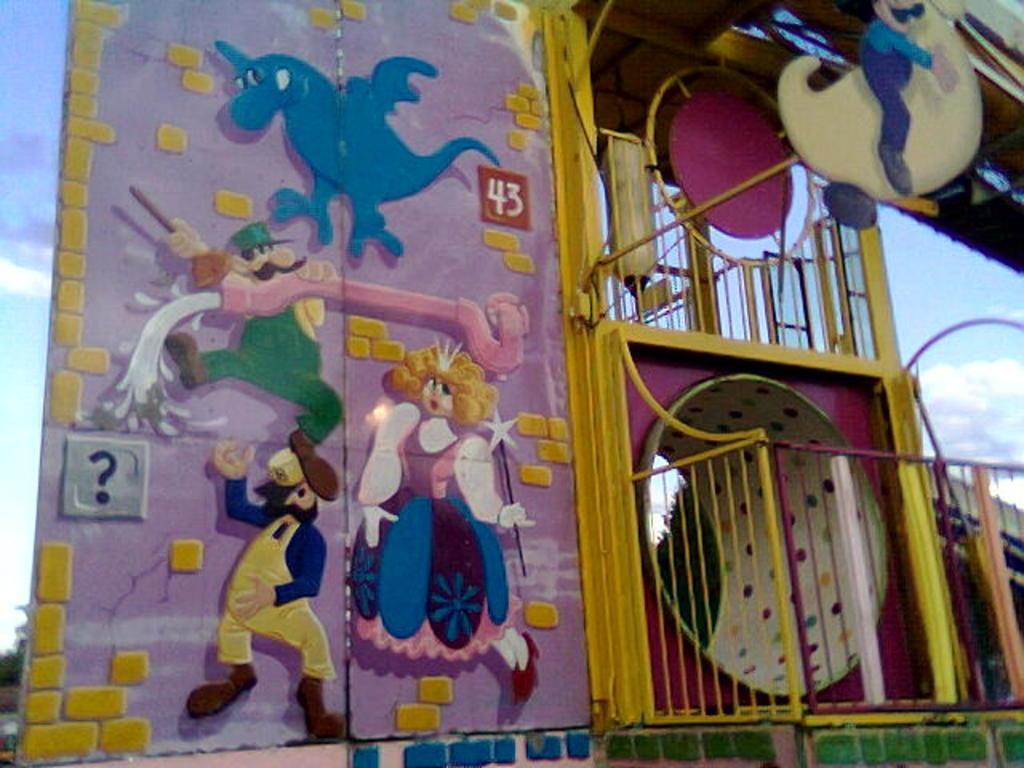How would you summarize this image in a sentence or two? In the center of the image we can see fun ride game. In the background we can see sky and clouds. 